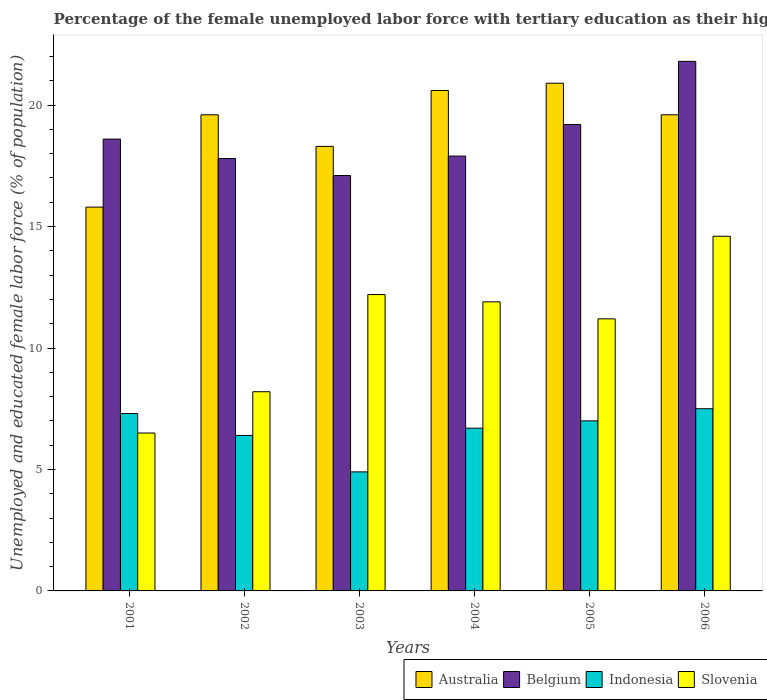How many groups of bars are there?
Your answer should be compact. 6. Are the number of bars per tick equal to the number of legend labels?
Your answer should be very brief. Yes. Are the number of bars on each tick of the X-axis equal?
Your response must be concise. Yes. How many bars are there on the 5th tick from the left?
Your answer should be very brief. 4. What is the label of the 1st group of bars from the left?
Your answer should be compact. 2001. In how many cases, is the number of bars for a given year not equal to the number of legend labels?
Your answer should be very brief. 0. What is the percentage of the unemployed female labor force with tertiary education in Slovenia in 2006?
Your answer should be compact. 14.6. Across all years, what is the maximum percentage of the unemployed female labor force with tertiary education in Belgium?
Provide a succinct answer. 21.8. In which year was the percentage of the unemployed female labor force with tertiary education in Belgium minimum?
Offer a very short reply. 2003. What is the total percentage of the unemployed female labor force with tertiary education in Slovenia in the graph?
Provide a short and direct response. 64.6. What is the difference between the percentage of the unemployed female labor force with tertiary education in Australia in 2003 and that in 2006?
Offer a terse response. -1.3. What is the difference between the percentage of the unemployed female labor force with tertiary education in Indonesia in 2002 and the percentage of the unemployed female labor force with tertiary education in Australia in 2004?
Give a very brief answer. -14.2. What is the average percentage of the unemployed female labor force with tertiary education in Indonesia per year?
Give a very brief answer. 6.63. In the year 2006, what is the difference between the percentage of the unemployed female labor force with tertiary education in Slovenia and percentage of the unemployed female labor force with tertiary education in Belgium?
Provide a short and direct response. -7.2. What is the ratio of the percentage of the unemployed female labor force with tertiary education in Belgium in 2001 to that in 2003?
Give a very brief answer. 1.09. What is the difference between the highest and the second highest percentage of the unemployed female labor force with tertiary education in Australia?
Make the answer very short. 0.3. What is the difference between the highest and the lowest percentage of the unemployed female labor force with tertiary education in Australia?
Give a very brief answer. 5.1. Is it the case that in every year, the sum of the percentage of the unemployed female labor force with tertiary education in Indonesia and percentage of the unemployed female labor force with tertiary education in Australia is greater than the sum of percentage of the unemployed female labor force with tertiary education in Belgium and percentage of the unemployed female labor force with tertiary education in Slovenia?
Ensure brevity in your answer.  No. Is it the case that in every year, the sum of the percentage of the unemployed female labor force with tertiary education in Slovenia and percentage of the unemployed female labor force with tertiary education in Belgium is greater than the percentage of the unemployed female labor force with tertiary education in Indonesia?
Provide a succinct answer. Yes. Does the graph contain any zero values?
Ensure brevity in your answer.  No. Does the graph contain grids?
Ensure brevity in your answer.  No. Where does the legend appear in the graph?
Make the answer very short. Bottom right. What is the title of the graph?
Your answer should be very brief. Percentage of the female unemployed labor force with tertiary education as their highest grade. What is the label or title of the Y-axis?
Your answer should be very brief. Unemployed and educated female labor force (% of population). What is the Unemployed and educated female labor force (% of population) in Australia in 2001?
Keep it short and to the point. 15.8. What is the Unemployed and educated female labor force (% of population) of Belgium in 2001?
Offer a very short reply. 18.6. What is the Unemployed and educated female labor force (% of population) in Indonesia in 2001?
Ensure brevity in your answer.  7.3. What is the Unemployed and educated female labor force (% of population) of Slovenia in 2001?
Offer a very short reply. 6.5. What is the Unemployed and educated female labor force (% of population) in Australia in 2002?
Give a very brief answer. 19.6. What is the Unemployed and educated female labor force (% of population) in Belgium in 2002?
Your answer should be compact. 17.8. What is the Unemployed and educated female labor force (% of population) of Indonesia in 2002?
Keep it short and to the point. 6.4. What is the Unemployed and educated female labor force (% of population) of Slovenia in 2002?
Keep it short and to the point. 8.2. What is the Unemployed and educated female labor force (% of population) of Australia in 2003?
Make the answer very short. 18.3. What is the Unemployed and educated female labor force (% of population) in Belgium in 2003?
Your answer should be compact. 17.1. What is the Unemployed and educated female labor force (% of population) of Indonesia in 2003?
Keep it short and to the point. 4.9. What is the Unemployed and educated female labor force (% of population) in Slovenia in 2003?
Your response must be concise. 12.2. What is the Unemployed and educated female labor force (% of population) in Australia in 2004?
Provide a succinct answer. 20.6. What is the Unemployed and educated female labor force (% of population) in Belgium in 2004?
Provide a short and direct response. 17.9. What is the Unemployed and educated female labor force (% of population) in Indonesia in 2004?
Provide a succinct answer. 6.7. What is the Unemployed and educated female labor force (% of population) in Slovenia in 2004?
Offer a very short reply. 11.9. What is the Unemployed and educated female labor force (% of population) of Australia in 2005?
Offer a terse response. 20.9. What is the Unemployed and educated female labor force (% of population) of Belgium in 2005?
Your answer should be compact. 19.2. What is the Unemployed and educated female labor force (% of population) in Indonesia in 2005?
Give a very brief answer. 7. What is the Unemployed and educated female labor force (% of population) of Slovenia in 2005?
Keep it short and to the point. 11.2. What is the Unemployed and educated female labor force (% of population) of Australia in 2006?
Provide a succinct answer. 19.6. What is the Unemployed and educated female labor force (% of population) in Belgium in 2006?
Your response must be concise. 21.8. What is the Unemployed and educated female labor force (% of population) in Indonesia in 2006?
Your response must be concise. 7.5. What is the Unemployed and educated female labor force (% of population) of Slovenia in 2006?
Your answer should be compact. 14.6. Across all years, what is the maximum Unemployed and educated female labor force (% of population) of Australia?
Provide a short and direct response. 20.9. Across all years, what is the maximum Unemployed and educated female labor force (% of population) of Belgium?
Ensure brevity in your answer.  21.8. Across all years, what is the maximum Unemployed and educated female labor force (% of population) of Indonesia?
Keep it short and to the point. 7.5. Across all years, what is the maximum Unemployed and educated female labor force (% of population) in Slovenia?
Provide a short and direct response. 14.6. Across all years, what is the minimum Unemployed and educated female labor force (% of population) in Australia?
Make the answer very short. 15.8. Across all years, what is the minimum Unemployed and educated female labor force (% of population) of Belgium?
Your answer should be compact. 17.1. Across all years, what is the minimum Unemployed and educated female labor force (% of population) in Indonesia?
Make the answer very short. 4.9. What is the total Unemployed and educated female labor force (% of population) of Australia in the graph?
Provide a short and direct response. 114.8. What is the total Unemployed and educated female labor force (% of population) in Belgium in the graph?
Offer a very short reply. 112.4. What is the total Unemployed and educated female labor force (% of population) in Indonesia in the graph?
Provide a short and direct response. 39.8. What is the total Unemployed and educated female labor force (% of population) in Slovenia in the graph?
Your answer should be very brief. 64.6. What is the difference between the Unemployed and educated female labor force (% of population) in Australia in 2001 and that in 2002?
Make the answer very short. -3.8. What is the difference between the Unemployed and educated female labor force (% of population) of Slovenia in 2001 and that in 2002?
Provide a succinct answer. -1.7. What is the difference between the Unemployed and educated female labor force (% of population) in Belgium in 2001 and that in 2003?
Provide a succinct answer. 1.5. What is the difference between the Unemployed and educated female labor force (% of population) in Indonesia in 2001 and that in 2003?
Give a very brief answer. 2.4. What is the difference between the Unemployed and educated female labor force (% of population) of Slovenia in 2001 and that in 2003?
Offer a very short reply. -5.7. What is the difference between the Unemployed and educated female labor force (% of population) of Belgium in 2001 and that in 2004?
Provide a succinct answer. 0.7. What is the difference between the Unemployed and educated female labor force (% of population) of Indonesia in 2001 and that in 2004?
Provide a succinct answer. 0.6. What is the difference between the Unemployed and educated female labor force (% of population) in Belgium in 2001 and that in 2005?
Offer a very short reply. -0.6. What is the difference between the Unemployed and educated female labor force (% of population) of Belgium in 2001 and that in 2006?
Your answer should be compact. -3.2. What is the difference between the Unemployed and educated female labor force (% of population) in Indonesia in 2001 and that in 2006?
Give a very brief answer. -0.2. What is the difference between the Unemployed and educated female labor force (% of population) in Belgium in 2002 and that in 2003?
Provide a succinct answer. 0.7. What is the difference between the Unemployed and educated female labor force (% of population) in Slovenia in 2002 and that in 2003?
Provide a short and direct response. -4. What is the difference between the Unemployed and educated female labor force (% of population) in Australia in 2002 and that in 2004?
Your answer should be very brief. -1. What is the difference between the Unemployed and educated female labor force (% of population) in Slovenia in 2002 and that in 2004?
Give a very brief answer. -3.7. What is the difference between the Unemployed and educated female labor force (% of population) in Belgium in 2002 and that in 2005?
Make the answer very short. -1.4. What is the difference between the Unemployed and educated female labor force (% of population) of Slovenia in 2002 and that in 2005?
Offer a terse response. -3. What is the difference between the Unemployed and educated female labor force (% of population) of Australia in 2003 and that in 2004?
Provide a succinct answer. -2.3. What is the difference between the Unemployed and educated female labor force (% of population) in Belgium in 2003 and that in 2004?
Your answer should be very brief. -0.8. What is the difference between the Unemployed and educated female labor force (% of population) in Indonesia in 2003 and that in 2004?
Your answer should be compact. -1.8. What is the difference between the Unemployed and educated female labor force (% of population) in Slovenia in 2003 and that in 2004?
Make the answer very short. 0.3. What is the difference between the Unemployed and educated female labor force (% of population) in Belgium in 2003 and that in 2005?
Provide a short and direct response. -2.1. What is the difference between the Unemployed and educated female labor force (% of population) of Indonesia in 2003 and that in 2005?
Offer a very short reply. -2.1. What is the difference between the Unemployed and educated female labor force (% of population) of Slovenia in 2003 and that in 2005?
Your answer should be compact. 1. What is the difference between the Unemployed and educated female labor force (% of population) of Indonesia in 2003 and that in 2006?
Give a very brief answer. -2.6. What is the difference between the Unemployed and educated female labor force (% of population) in Indonesia in 2004 and that in 2005?
Make the answer very short. -0.3. What is the difference between the Unemployed and educated female labor force (% of population) of Indonesia in 2004 and that in 2006?
Offer a very short reply. -0.8. What is the difference between the Unemployed and educated female labor force (% of population) of Slovenia in 2004 and that in 2006?
Keep it short and to the point. -2.7. What is the difference between the Unemployed and educated female labor force (% of population) in Indonesia in 2005 and that in 2006?
Provide a succinct answer. -0.5. What is the difference between the Unemployed and educated female labor force (% of population) of Australia in 2001 and the Unemployed and educated female labor force (% of population) of Indonesia in 2002?
Ensure brevity in your answer.  9.4. What is the difference between the Unemployed and educated female labor force (% of population) in Australia in 2001 and the Unemployed and educated female labor force (% of population) in Slovenia in 2002?
Provide a short and direct response. 7.6. What is the difference between the Unemployed and educated female labor force (% of population) of Belgium in 2001 and the Unemployed and educated female labor force (% of population) of Indonesia in 2002?
Provide a succinct answer. 12.2. What is the difference between the Unemployed and educated female labor force (% of population) in Belgium in 2001 and the Unemployed and educated female labor force (% of population) in Slovenia in 2002?
Your response must be concise. 10.4. What is the difference between the Unemployed and educated female labor force (% of population) of Indonesia in 2001 and the Unemployed and educated female labor force (% of population) of Slovenia in 2002?
Ensure brevity in your answer.  -0.9. What is the difference between the Unemployed and educated female labor force (% of population) of Indonesia in 2001 and the Unemployed and educated female labor force (% of population) of Slovenia in 2003?
Your answer should be compact. -4.9. What is the difference between the Unemployed and educated female labor force (% of population) in Australia in 2001 and the Unemployed and educated female labor force (% of population) in Belgium in 2004?
Keep it short and to the point. -2.1. What is the difference between the Unemployed and educated female labor force (% of population) in Australia in 2001 and the Unemployed and educated female labor force (% of population) in Indonesia in 2004?
Your response must be concise. 9.1. What is the difference between the Unemployed and educated female labor force (% of population) of Australia in 2001 and the Unemployed and educated female labor force (% of population) of Slovenia in 2004?
Make the answer very short. 3.9. What is the difference between the Unemployed and educated female labor force (% of population) of Belgium in 2001 and the Unemployed and educated female labor force (% of population) of Indonesia in 2004?
Ensure brevity in your answer.  11.9. What is the difference between the Unemployed and educated female labor force (% of population) in Australia in 2001 and the Unemployed and educated female labor force (% of population) in Belgium in 2005?
Your answer should be very brief. -3.4. What is the difference between the Unemployed and educated female labor force (% of population) of Australia in 2001 and the Unemployed and educated female labor force (% of population) of Slovenia in 2005?
Ensure brevity in your answer.  4.6. What is the difference between the Unemployed and educated female labor force (% of population) in Australia in 2001 and the Unemployed and educated female labor force (% of population) in Indonesia in 2006?
Your answer should be very brief. 8.3. What is the difference between the Unemployed and educated female labor force (% of population) of Belgium in 2001 and the Unemployed and educated female labor force (% of population) of Indonesia in 2006?
Your response must be concise. 11.1. What is the difference between the Unemployed and educated female labor force (% of population) of Belgium in 2001 and the Unemployed and educated female labor force (% of population) of Slovenia in 2006?
Give a very brief answer. 4. What is the difference between the Unemployed and educated female labor force (% of population) of Indonesia in 2001 and the Unemployed and educated female labor force (% of population) of Slovenia in 2006?
Your answer should be compact. -7.3. What is the difference between the Unemployed and educated female labor force (% of population) in Australia in 2002 and the Unemployed and educated female labor force (% of population) in Belgium in 2003?
Provide a short and direct response. 2.5. What is the difference between the Unemployed and educated female labor force (% of population) in Australia in 2002 and the Unemployed and educated female labor force (% of population) in Slovenia in 2003?
Provide a succinct answer. 7.4. What is the difference between the Unemployed and educated female labor force (% of population) of Australia in 2002 and the Unemployed and educated female labor force (% of population) of Indonesia in 2004?
Your response must be concise. 12.9. What is the difference between the Unemployed and educated female labor force (% of population) in Australia in 2002 and the Unemployed and educated female labor force (% of population) in Belgium in 2005?
Your response must be concise. 0.4. What is the difference between the Unemployed and educated female labor force (% of population) of Australia in 2002 and the Unemployed and educated female labor force (% of population) of Indonesia in 2005?
Ensure brevity in your answer.  12.6. What is the difference between the Unemployed and educated female labor force (% of population) of Belgium in 2002 and the Unemployed and educated female labor force (% of population) of Indonesia in 2005?
Give a very brief answer. 10.8. What is the difference between the Unemployed and educated female labor force (% of population) of Indonesia in 2002 and the Unemployed and educated female labor force (% of population) of Slovenia in 2005?
Offer a very short reply. -4.8. What is the difference between the Unemployed and educated female labor force (% of population) in Australia in 2002 and the Unemployed and educated female labor force (% of population) in Belgium in 2006?
Provide a short and direct response. -2.2. What is the difference between the Unemployed and educated female labor force (% of population) in Australia in 2002 and the Unemployed and educated female labor force (% of population) in Slovenia in 2006?
Ensure brevity in your answer.  5. What is the difference between the Unemployed and educated female labor force (% of population) in Belgium in 2002 and the Unemployed and educated female labor force (% of population) in Indonesia in 2006?
Your answer should be very brief. 10.3. What is the difference between the Unemployed and educated female labor force (% of population) in Indonesia in 2002 and the Unemployed and educated female labor force (% of population) in Slovenia in 2006?
Keep it short and to the point. -8.2. What is the difference between the Unemployed and educated female labor force (% of population) of Australia in 2003 and the Unemployed and educated female labor force (% of population) of Indonesia in 2004?
Ensure brevity in your answer.  11.6. What is the difference between the Unemployed and educated female labor force (% of population) of Australia in 2003 and the Unemployed and educated female labor force (% of population) of Slovenia in 2004?
Give a very brief answer. 6.4. What is the difference between the Unemployed and educated female labor force (% of population) in Belgium in 2003 and the Unemployed and educated female labor force (% of population) in Slovenia in 2004?
Make the answer very short. 5.2. What is the difference between the Unemployed and educated female labor force (% of population) of Australia in 2003 and the Unemployed and educated female labor force (% of population) of Indonesia in 2005?
Keep it short and to the point. 11.3. What is the difference between the Unemployed and educated female labor force (% of population) in Belgium in 2003 and the Unemployed and educated female labor force (% of population) in Slovenia in 2005?
Your answer should be compact. 5.9. What is the difference between the Unemployed and educated female labor force (% of population) in Australia in 2003 and the Unemployed and educated female labor force (% of population) in Belgium in 2006?
Your response must be concise. -3.5. What is the difference between the Unemployed and educated female labor force (% of population) of Australia in 2003 and the Unemployed and educated female labor force (% of population) of Indonesia in 2006?
Give a very brief answer. 10.8. What is the difference between the Unemployed and educated female labor force (% of population) in Australia in 2003 and the Unemployed and educated female labor force (% of population) in Slovenia in 2006?
Make the answer very short. 3.7. What is the difference between the Unemployed and educated female labor force (% of population) in Belgium in 2003 and the Unemployed and educated female labor force (% of population) in Indonesia in 2006?
Offer a very short reply. 9.6. What is the difference between the Unemployed and educated female labor force (% of population) of Belgium in 2004 and the Unemployed and educated female labor force (% of population) of Indonesia in 2005?
Give a very brief answer. 10.9. What is the difference between the Unemployed and educated female labor force (% of population) of Indonesia in 2004 and the Unemployed and educated female labor force (% of population) of Slovenia in 2005?
Make the answer very short. -4.5. What is the difference between the Unemployed and educated female labor force (% of population) in Australia in 2004 and the Unemployed and educated female labor force (% of population) in Belgium in 2006?
Your answer should be very brief. -1.2. What is the difference between the Unemployed and educated female labor force (% of population) of Australia in 2004 and the Unemployed and educated female labor force (% of population) of Indonesia in 2006?
Your answer should be compact. 13.1. What is the difference between the Unemployed and educated female labor force (% of population) in Belgium in 2004 and the Unemployed and educated female labor force (% of population) in Slovenia in 2006?
Give a very brief answer. 3.3. What is the difference between the Unemployed and educated female labor force (% of population) of Australia in 2005 and the Unemployed and educated female labor force (% of population) of Belgium in 2006?
Your answer should be compact. -0.9. What is the difference between the Unemployed and educated female labor force (% of population) in Australia in 2005 and the Unemployed and educated female labor force (% of population) in Slovenia in 2006?
Give a very brief answer. 6.3. What is the difference between the Unemployed and educated female labor force (% of population) of Belgium in 2005 and the Unemployed and educated female labor force (% of population) of Indonesia in 2006?
Make the answer very short. 11.7. What is the difference between the Unemployed and educated female labor force (% of population) in Indonesia in 2005 and the Unemployed and educated female labor force (% of population) in Slovenia in 2006?
Provide a succinct answer. -7.6. What is the average Unemployed and educated female labor force (% of population) of Australia per year?
Provide a short and direct response. 19.13. What is the average Unemployed and educated female labor force (% of population) in Belgium per year?
Your answer should be compact. 18.73. What is the average Unemployed and educated female labor force (% of population) in Indonesia per year?
Provide a short and direct response. 6.63. What is the average Unemployed and educated female labor force (% of population) in Slovenia per year?
Offer a very short reply. 10.77. In the year 2001, what is the difference between the Unemployed and educated female labor force (% of population) of Australia and Unemployed and educated female labor force (% of population) of Belgium?
Your answer should be very brief. -2.8. In the year 2001, what is the difference between the Unemployed and educated female labor force (% of population) of Australia and Unemployed and educated female labor force (% of population) of Slovenia?
Offer a very short reply. 9.3. In the year 2002, what is the difference between the Unemployed and educated female labor force (% of population) of Australia and Unemployed and educated female labor force (% of population) of Belgium?
Keep it short and to the point. 1.8. In the year 2002, what is the difference between the Unemployed and educated female labor force (% of population) of Australia and Unemployed and educated female labor force (% of population) of Indonesia?
Keep it short and to the point. 13.2. In the year 2002, what is the difference between the Unemployed and educated female labor force (% of population) in Belgium and Unemployed and educated female labor force (% of population) in Indonesia?
Provide a succinct answer. 11.4. In the year 2003, what is the difference between the Unemployed and educated female labor force (% of population) of Australia and Unemployed and educated female labor force (% of population) of Belgium?
Your response must be concise. 1.2. In the year 2003, what is the difference between the Unemployed and educated female labor force (% of population) of Australia and Unemployed and educated female labor force (% of population) of Indonesia?
Provide a short and direct response. 13.4. In the year 2003, what is the difference between the Unemployed and educated female labor force (% of population) of Australia and Unemployed and educated female labor force (% of population) of Slovenia?
Make the answer very short. 6.1. In the year 2004, what is the difference between the Unemployed and educated female labor force (% of population) in Australia and Unemployed and educated female labor force (% of population) in Slovenia?
Offer a very short reply. 8.7. In the year 2005, what is the difference between the Unemployed and educated female labor force (% of population) of Australia and Unemployed and educated female labor force (% of population) of Slovenia?
Make the answer very short. 9.7. In the year 2005, what is the difference between the Unemployed and educated female labor force (% of population) of Indonesia and Unemployed and educated female labor force (% of population) of Slovenia?
Provide a succinct answer. -4.2. In the year 2006, what is the difference between the Unemployed and educated female labor force (% of population) of Australia and Unemployed and educated female labor force (% of population) of Belgium?
Make the answer very short. -2.2. In the year 2006, what is the difference between the Unemployed and educated female labor force (% of population) in Australia and Unemployed and educated female labor force (% of population) in Slovenia?
Provide a succinct answer. 5. In the year 2006, what is the difference between the Unemployed and educated female labor force (% of population) of Indonesia and Unemployed and educated female labor force (% of population) of Slovenia?
Your answer should be very brief. -7.1. What is the ratio of the Unemployed and educated female labor force (% of population) in Australia in 2001 to that in 2002?
Offer a very short reply. 0.81. What is the ratio of the Unemployed and educated female labor force (% of population) of Belgium in 2001 to that in 2002?
Your answer should be compact. 1.04. What is the ratio of the Unemployed and educated female labor force (% of population) in Indonesia in 2001 to that in 2002?
Ensure brevity in your answer.  1.14. What is the ratio of the Unemployed and educated female labor force (% of population) of Slovenia in 2001 to that in 2002?
Your answer should be compact. 0.79. What is the ratio of the Unemployed and educated female labor force (% of population) in Australia in 2001 to that in 2003?
Provide a succinct answer. 0.86. What is the ratio of the Unemployed and educated female labor force (% of population) of Belgium in 2001 to that in 2003?
Make the answer very short. 1.09. What is the ratio of the Unemployed and educated female labor force (% of population) in Indonesia in 2001 to that in 2003?
Keep it short and to the point. 1.49. What is the ratio of the Unemployed and educated female labor force (% of population) in Slovenia in 2001 to that in 2003?
Your response must be concise. 0.53. What is the ratio of the Unemployed and educated female labor force (% of population) of Australia in 2001 to that in 2004?
Provide a short and direct response. 0.77. What is the ratio of the Unemployed and educated female labor force (% of population) of Belgium in 2001 to that in 2004?
Provide a short and direct response. 1.04. What is the ratio of the Unemployed and educated female labor force (% of population) of Indonesia in 2001 to that in 2004?
Make the answer very short. 1.09. What is the ratio of the Unemployed and educated female labor force (% of population) in Slovenia in 2001 to that in 2004?
Give a very brief answer. 0.55. What is the ratio of the Unemployed and educated female labor force (% of population) of Australia in 2001 to that in 2005?
Offer a very short reply. 0.76. What is the ratio of the Unemployed and educated female labor force (% of population) in Belgium in 2001 to that in 2005?
Keep it short and to the point. 0.97. What is the ratio of the Unemployed and educated female labor force (% of population) of Indonesia in 2001 to that in 2005?
Your answer should be very brief. 1.04. What is the ratio of the Unemployed and educated female labor force (% of population) in Slovenia in 2001 to that in 2005?
Ensure brevity in your answer.  0.58. What is the ratio of the Unemployed and educated female labor force (% of population) of Australia in 2001 to that in 2006?
Give a very brief answer. 0.81. What is the ratio of the Unemployed and educated female labor force (% of population) of Belgium in 2001 to that in 2006?
Provide a short and direct response. 0.85. What is the ratio of the Unemployed and educated female labor force (% of population) in Indonesia in 2001 to that in 2006?
Your answer should be very brief. 0.97. What is the ratio of the Unemployed and educated female labor force (% of population) in Slovenia in 2001 to that in 2006?
Your response must be concise. 0.45. What is the ratio of the Unemployed and educated female labor force (% of population) in Australia in 2002 to that in 2003?
Ensure brevity in your answer.  1.07. What is the ratio of the Unemployed and educated female labor force (% of population) of Belgium in 2002 to that in 2003?
Offer a very short reply. 1.04. What is the ratio of the Unemployed and educated female labor force (% of population) of Indonesia in 2002 to that in 2003?
Keep it short and to the point. 1.31. What is the ratio of the Unemployed and educated female labor force (% of population) in Slovenia in 2002 to that in 2003?
Provide a short and direct response. 0.67. What is the ratio of the Unemployed and educated female labor force (% of population) in Australia in 2002 to that in 2004?
Offer a very short reply. 0.95. What is the ratio of the Unemployed and educated female labor force (% of population) of Indonesia in 2002 to that in 2004?
Ensure brevity in your answer.  0.96. What is the ratio of the Unemployed and educated female labor force (% of population) in Slovenia in 2002 to that in 2004?
Your answer should be compact. 0.69. What is the ratio of the Unemployed and educated female labor force (% of population) in Australia in 2002 to that in 2005?
Your answer should be compact. 0.94. What is the ratio of the Unemployed and educated female labor force (% of population) in Belgium in 2002 to that in 2005?
Provide a succinct answer. 0.93. What is the ratio of the Unemployed and educated female labor force (% of population) in Indonesia in 2002 to that in 2005?
Your answer should be very brief. 0.91. What is the ratio of the Unemployed and educated female labor force (% of population) in Slovenia in 2002 to that in 2005?
Keep it short and to the point. 0.73. What is the ratio of the Unemployed and educated female labor force (% of population) in Australia in 2002 to that in 2006?
Your answer should be compact. 1. What is the ratio of the Unemployed and educated female labor force (% of population) in Belgium in 2002 to that in 2006?
Your answer should be very brief. 0.82. What is the ratio of the Unemployed and educated female labor force (% of population) in Indonesia in 2002 to that in 2006?
Make the answer very short. 0.85. What is the ratio of the Unemployed and educated female labor force (% of population) of Slovenia in 2002 to that in 2006?
Ensure brevity in your answer.  0.56. What is the ratio of the Unemployed and educated female labor force (% of population) of Australia in 2003 to that in 2004?
Give a very brief answer. 0.89. What is the ratio of the Unemployed and educated female labor force (% of population) of Belgium in 2003 to that in 2004?
Your answer should be very brief. 0.96. What is the ratio of the Unemployed and educated female labor force (% of population) of Indonesia in 2003 to that in 2004?
Give a very brief answer. 0.73. What is the ratio of the Unemployed and educated female labor force (% of population) of Slovenia in 2003 to that in 2004?
Give a very brief answer. 1.03. What is the ratio of the Unemployed and educated female labor force (% of population) of Australia in 2003 to that in 2005?
Your response must be concise. 0.88. What is the ratio of the Unemployed and educated female labor force (% of population) of Belgium in 2003 to that in 2005?
Ensure brevity in your answer.  0.89. What is the ratio of the Unemployed and educated female labor force (% of population) in Slovenia in 2003 to that in 2005?
Your response must be concise. 1.09. What is the ratio of the Unemployed and educated female labor force (% of population) in Australia in 2003 to that in 2006?
Your response must be concise. 0.93. What is the ratio of the Unemployed and educated female labor force (% of population) of Belgium in 2003 to that in 2006?
Keep it short and to the point. 0.78. What is the ratio of the Unemployed and educated female labor force (% of population) in Indonesia in 2003 to that in 2006?
Provide a succinct answer. 0.65. What is the ratio of the Unemployed and educated female labor force (% of population) in Slovenia in 2003 to that in 2006?
Your answer should be very brief. 0.84. What is the ratio of the Unemployed and educated female labor force (% of population) in Australia in 2004 to that in 2005?
Your response must be concise. 0.99. What is the ratio of the Unemployed and educated female labor force (% of population) in Belgium in 2004 to that in 2005?
Keep it short and to the point. 0.93. What is the ratio of the Unemployed and educated female labor force (% of population) in Indonesia in 2004 to that in 2005?
Your answer should be very brief. 0.96. What is the ratio of the Unemployed and educated female labor force (% of population) of Australia in 2004 to that in 2006?
Your answer should be compact. 1.05. What is the ratio of the Unemployed and educated female labor force (% of population) in Belgium in 2004 to that in 2006?
Your answer should be compact. 0.82. What is the ratio of the Unemployed and educated female labor force (% of population) in Indonesia in 2004 to that in 2006?
Make the answer very short. 0.89. What is the ratio of the Unemployed and educated female labor force (% of population) in Slovenia in 2004 to that in 2006?
Provide a short and direct response. 0.82. What is the ratio of the Unemployed and educated female labor force (% of population) of Australia in 2005 to that in 2006?
Offer a terse response. 1.07. What is the ratio of the Unemployed and educated female labor force (% of population) of Belgium in 2005 to that in 2006?
Make the answer very short. 0.88. What is the ratio of the Unemployed and educated female labor force (% of population) of Slovenia in 2005 to that in 2006?
Your response must be concise. 0.77. What is the difference between the highest and the second highest Unemployed and educated female labor force (% of population) in Belgium?
Provide a succinct answer. 2.6. What is the difference between the highest and the lowest Unemployed and educated female labor force (% of population) in Belgium?
Provide a short and direct response. 4.7. What is the difference between the highest and the lowest Unemployed and educated female labor force (% of population) of Indonesia?
Offer a very short reply. 2.6. What is the difference between the highest and the lowest Unemployed and educated female labor force (% of population) of Slovenia?
Your response must be concise. 8.1. 